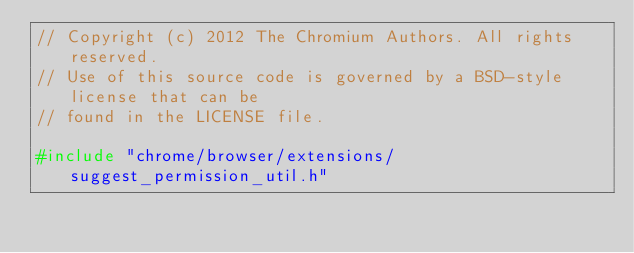Convert code to text. <code><loc_0><loc_0><loc_500><loc_500><_C++_>// Copyright (c) 2012 The Chromium Authors. All rights reserved.
// Use of this source code is governed by a BSD-style license that can be
// found in the LICENSE file.

#include "chrome/browser/extensions/suggest_permission_util.h"
</code> 